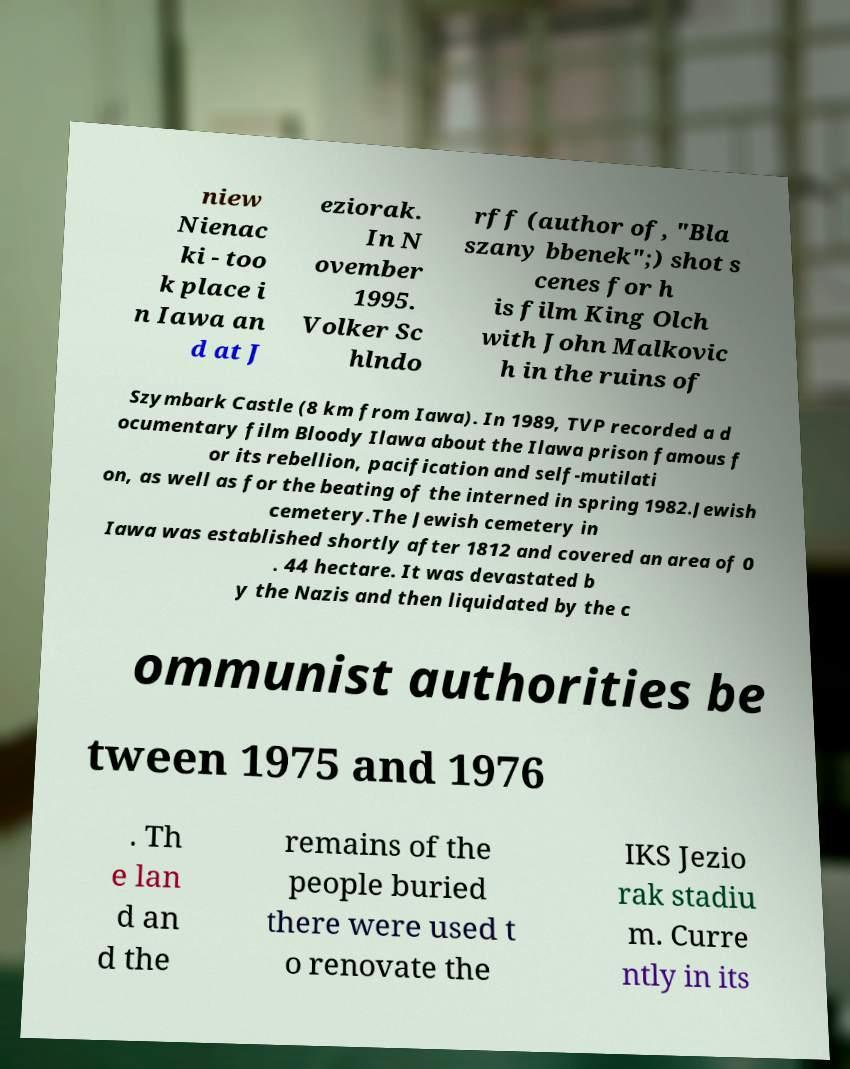For documentation purposes, I need the text within this image transcribed. Could you provide that? niew Nienac ki - too k place i n Iawa an d at J eziorak. In N ovember 1995. Volker Sc hlndo rff (author of, "Bla szany bbenek";) shot s cenes for h is film King Olch with John Malkovic h in the ruins of Szymbark Castle (8 km from Iawa). In 1989, TVP recorded a d ocumentary film Bloody Ilawa about the Ilawa prison famous f or its rebellion, pacification and self-mutilati on, as well as for the beating of the interned in spring 1982.Jewish cemetery.The Jewish cemetery in Iawa was established shortly after 1812 and covered an area of 0 . 44 hectare. It was devastated b y the Nazis and then liquidated by the c ommunist authorities be tween 1975 and 1976 . Th e lan d an d the remains of the people buried there were used t o renovate the IKS Jezio rak stadiu m. Curre ntly in its 